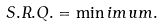<formula> <loc_0><loc_0><loc_500><loc_500>S . R . Q . = \min i m u m .</formula> 